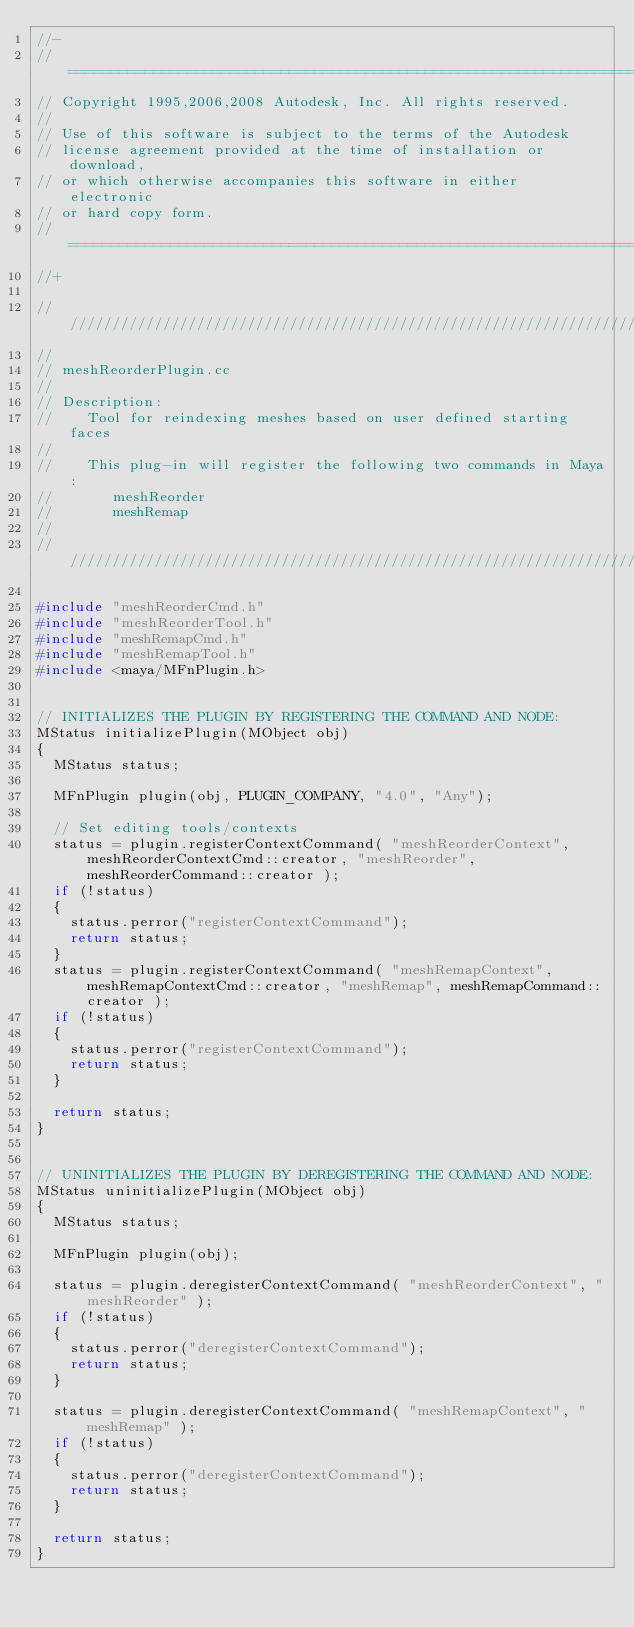Convert code to text. <code><loc_0><loc_0><loc_500><loc_500><_C++_>//-
// ==========================================================================
// Copyright 1995,2006,2008 Autodesk, Inc. All rights reserved.
//
// Use of this software is subject to the terms of the Autodesk
// license agreement provided at the time of installation or download,
// or which otherwise accompanies this software in either electronic
// or hard copy form.
// ==========================================================================
//+

////////////////////////////////////////////////////////////////////////
// 
// meshReorderPlugin.cc
// 
// Description:
//    Tool for reindexing meshes based on user defined starting faces
//
//    This plug-in will register the following two commands in Maya:
//       meshReorder
//       meshRemap
// 
////////////////////////////////////////////////////////////////////////

#include "meshReorderCmd.h"
#include "meshReorderTool.h"
#include "meshRemapCmd.h"
#include "meshRemapTool.h"
#include <maya/MFnPlugin.h>


// INITIALIZES THE PLUGIN BY REGISTERING THE COMMAND AND NODE:
MStatus initializePlugin(MObject obj)
{
	MStatus status;

	MFnPlugin plugin(obj, PLUGIN_COMPANY, "4.0", "Any");

	// Set editing tools/contexts
	status = plugin.registerContextCommand( "meshReorderContext", meshReorderContextCmd::creator, "meshReorder", meshReorderCommand::creator );
	if (!status)
	{
	  status.perror("registerContextCommand");
	  return status;
	}
	status = plugin.registerContextCommand( "meshRemapContext", meshRemapContextCmd::creator, "meshRemap", meshRemapCommand::creator );
	if (!status)
	{
	  status.perror("registerContextCommand");
	  return status;
	}

	return status;
}


// UNINITIALIZES THE PLUGIN BY DEREGISTERING THE COMMAND AND NODE:
MStatus uninitializePlugin(MObject obj)
{
	MStatus status;

	MFnPlugin plugin(obj);

	status = plugin.deregisterContextCommand( "meshReorderContext", "meshReorder" );
	if (!status)
	{
		status.perror("deregisterContextCommand");
		return status;
	}

	status = plugin.deregisterContextCommand( "meshRemapContext", "meshRemap" );
	if (!status)
	{
		status.perror("deregisterContextCommand");
		return status;
	}

	return status;
}
</code> 